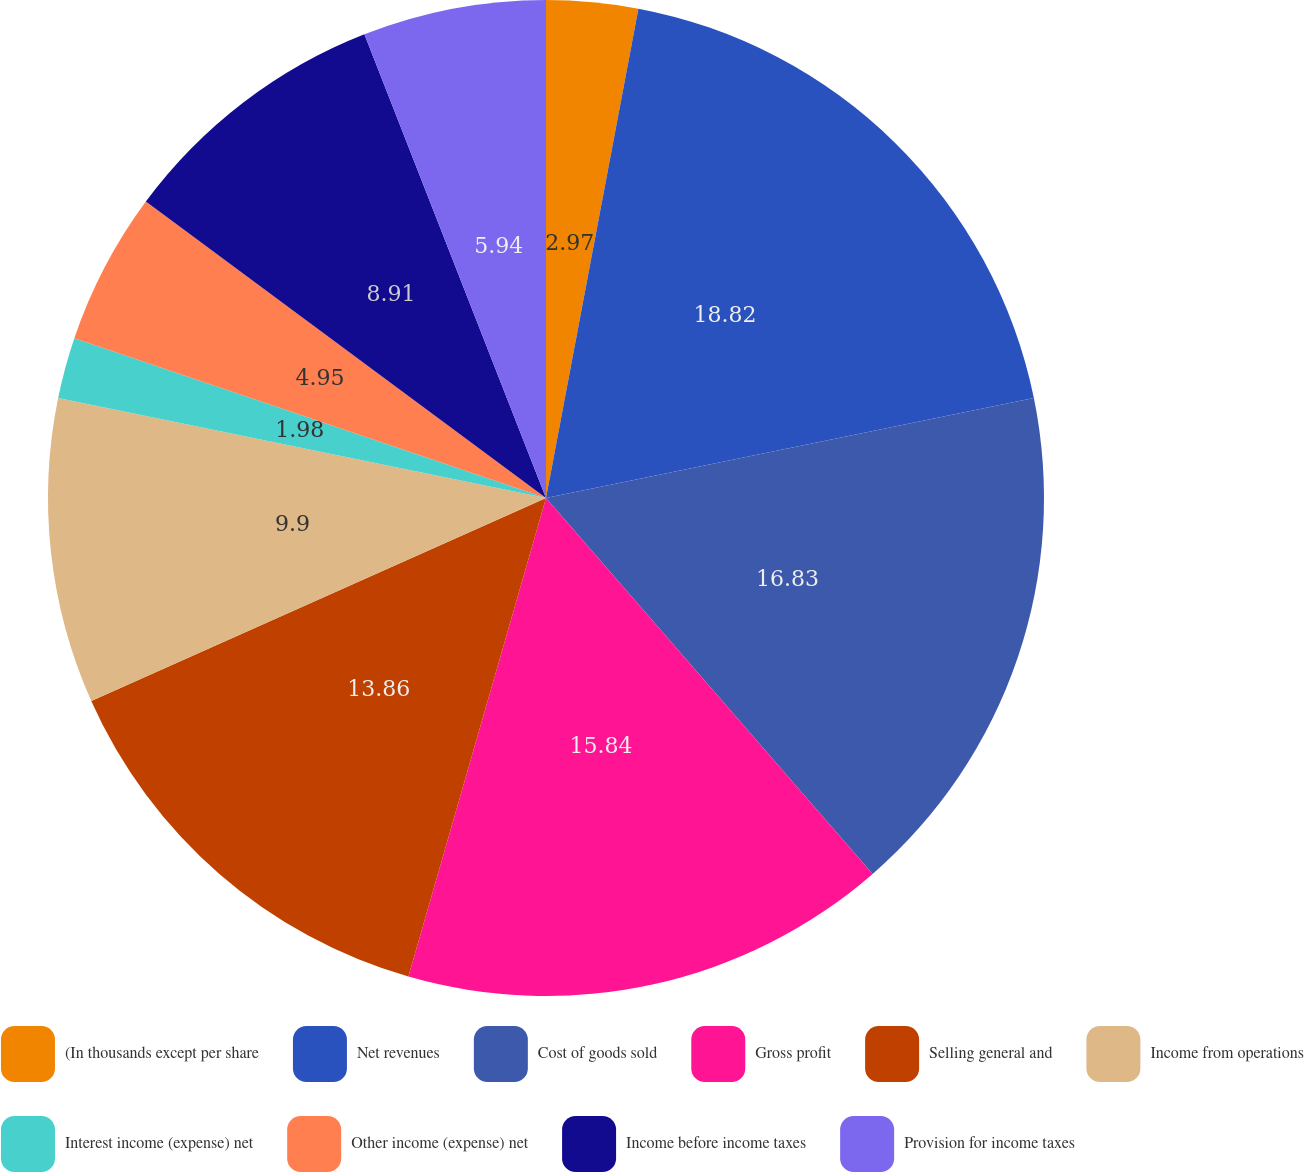Convert chart. <chart><loc_0><loc_0><loc_500><loc_500><pie_chart><fcel>(In thousands except per share<fcel>Net revenues<fcel>Cost of goods sold<fcel>Gross profit<fcel>Selling general and<fcel>Income from operations<fcel>Interest income (expense) net<fcel>Other income (expense) net<fcel>Income before income taxes<fcel>Provision for income taxes<nl><fcel>2.97%<fcel>18.81%<fcel>16.83%<fcel>15.84%<fcel>13.86%<fcel>9.9%<fcel>1.98%<fcel>4.95%<fcel>8.91%<fcel>5.94%<nl></chart> 